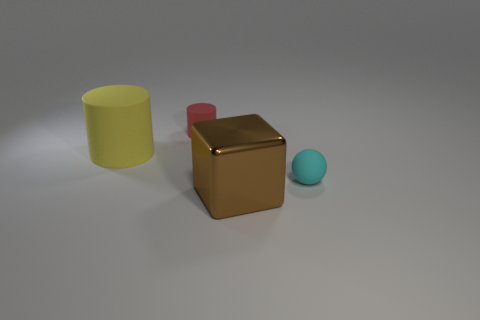Add 2 small things. How many objects exist? 6 Subtract all blocks. How many objects are left? 3 Add 2 yellow matte cylinders. How many yellow matte cylinders are left? 3 Add 3 large red shiny cylinders. How many large red shiny cylinders exist? 3 Subtract 0 purple cylinders. How many objects are left? 4 Subtract all spheres. Subtract all cyan rubber things. How many objects are left? 2 